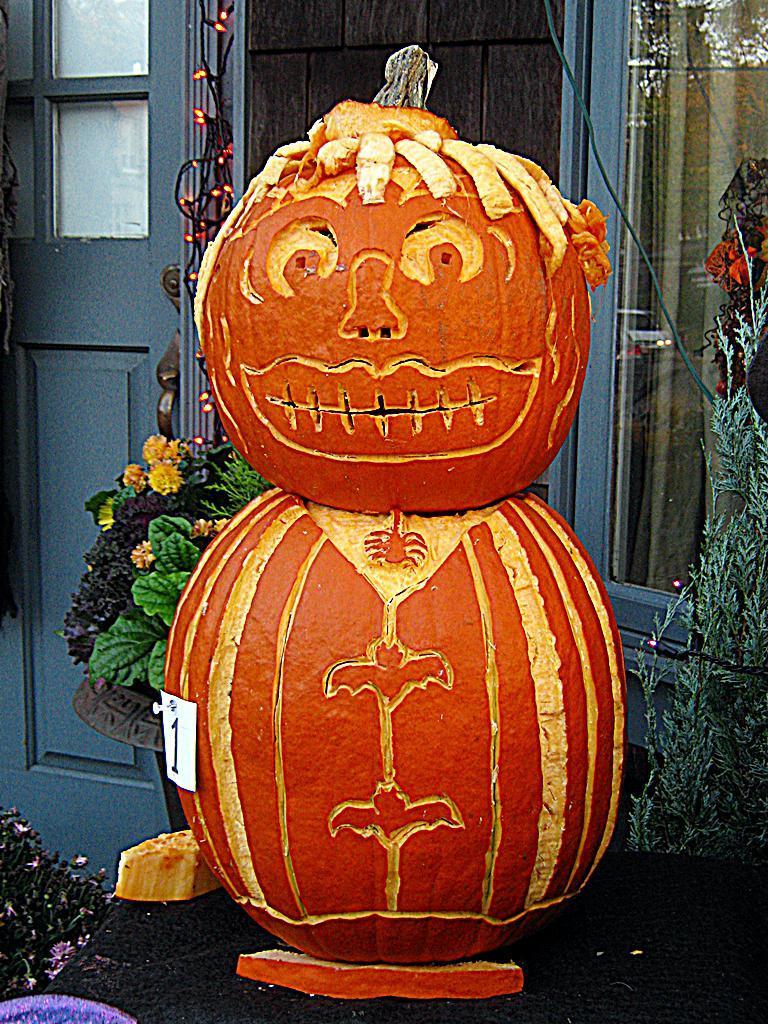In one or two sentences, can you explain what this image depicts? In this picture, we can see a decorative object in orange color on the ground, we can see the glass door, ground, plants, and some object in the bottom left side of the picture. 